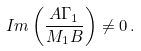<formula> <loc_0><loc_0><loc_500><loc_500>I m \left ( \frac { A \Gamma _ { 1 } } { M _ { 1 } B } \right ) \ne 0 \, .</formula> 